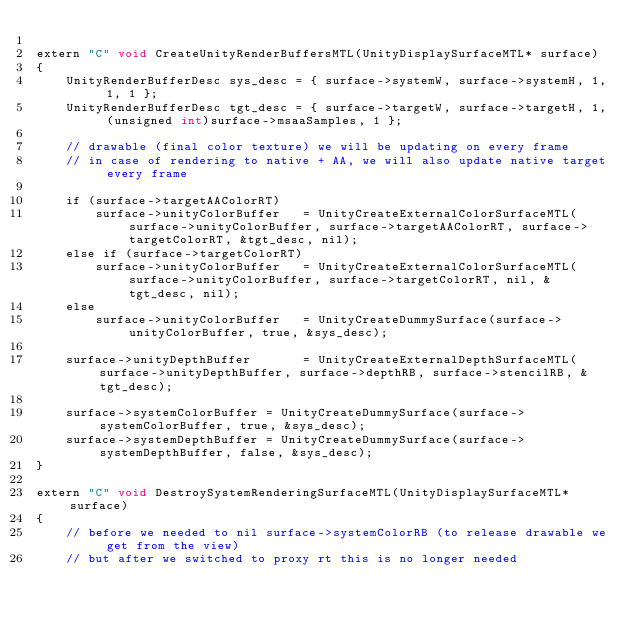Convert code to text. <code><loc_0><loc_0><loc_500><loc_500><_ObjectiveC_>
extern "C" void CreateUnityRenderBuffersMTL(UnityDisplaySurfaceMTL* surface)
{
    UnityRenderBufferDesc sys_desc = { surface->systemW, surface->systemH, 1, 1, 1 };
    UnityRenderBufferDesc tgt_desc = { surface->targetW, surface->targetH, 1, (unsigned int)surface->msaaSamples, 1 };

    // drawable (final color texture) we will be updating on every frame
    // in case of rendering to native + AA, we will also update native target every frame

    if (surface->targetAAColorRT)
        surface->unityColorBuffer   = UnityCreateExternalColorSurfaceMTL(surface->unityColorBuffer, surface->targetAAColorRT, surface->targetColorRT, &tgt_desc, nil);
    else if (surface->targetColorRT)
        surface->unityColorBuffer   = UnityCreateExternalColorSurfaceMTL(surface->unityColorBuffer, surface->targetColorRT, nil, &tgt_desc, nil);
    else
        surface->unityColorBuffer   = UnityCreateDummySurface(surface->unityColorBuffer, true, &sys_desc);

    surface->unityDepthBuffer       = UnityCreateExternalDepthSurfaceMTL(surface->unityDepthBuffer, surface->depthRB, surface->stencilRB, &tgt_desc);

    surface->systemColorBuffer = UnityCreateDummySurface(surface->systemColorBuffer, true, &sys_desc);
    surface->systemDepthBuffer = UnityCreateDummySurface(surface->systemDepthBuffer, false, &sys_desc);
}

extern "C" void DestroySystemRenderingSurfaceMTL(UnityDisplaySurfaceMTL* surface)
{
    // before we needed to nil surface->systemColorRB (to release drawable we get from the view)
    // but after we switched to proxy rt this is no longer needed</code> 